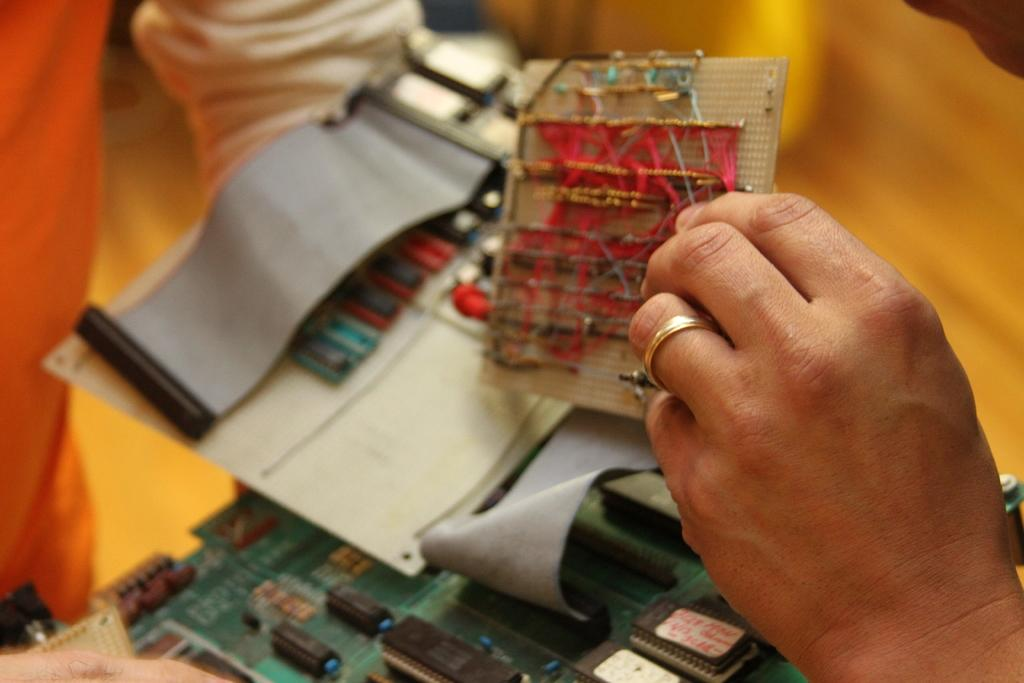What is the person in the image holding? The person is holding a breadboard in the image. What can be seen in the background of the image? There are electronic components visible in the background of the image. What type of oil is being used to lubricate the rod in the image? There is no rod or oil present in the image; it features a person holding a breadboard and electronic components in the background. 